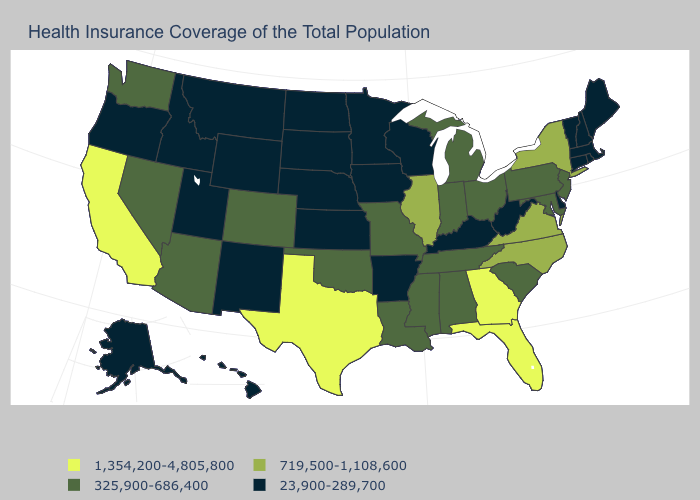Among the states that border West Virginia , does Maryland have the lowest value?
Answer briefly. No. Which states have the highest value in the USA?
Write a very short answer. California, Florida, Georgia, Texas. What is the value of North Dakota?
Answer briefly. 23,900-289,700. What is the highest value in states that border New Mexico?
Give a very brief answer. 1,354,200-4,805,800. Name the states that have a value in the range 719,500-1,108,600?
Give a very brief answer. Illinois, New York, North Carolina, Virginia. What is the value of New Hampshire?
Answer briefly. 23,900-289,700. Does Colorado have a higher value than New Hampshire?
Be succinct. Yes. What is the value of Hawaii?
Keep it brief. 23,900-289,700. What is the highest value in the MidWest ?
Write a very short answer. 719,500-1,108,600. Which states hav the highest value in the Northeast?
Concise answer only. New York. Name the states that have a value in the range 325,900-686,400?
Concise answer only. Alabama, Arizona, Colorado, Indiana, Louisiana, Maryland, Michigan, Mississippi, Missouri, Nevada, New Jersey, Ohio, Oklahoma, Pennsylvania, South Carolina, Tennessee, Washington. Name the states that have a value in the range 719,500-1,108,600?
Short answer required. Illinois, New York, North Carolina, Virginia. Name the states that have a value in the range 325,900-686,400?
Give a very brief answer. Alabama, Arizona, Colorado, Indiana, Louisiana, Maryland, Michigan, Mississippi, Missouri, Nevada, New Jersey, Ohio, Oklahoma, Pennsylvania, South Carolina, Tennessee, Washington. What is the value of Montana?
Keep it brief. 23,900-289,700. Name the states that have a value in the range 719,500-1,108,600?
Concise answer only. Illinois, New York, North Carolina, Virginia. 